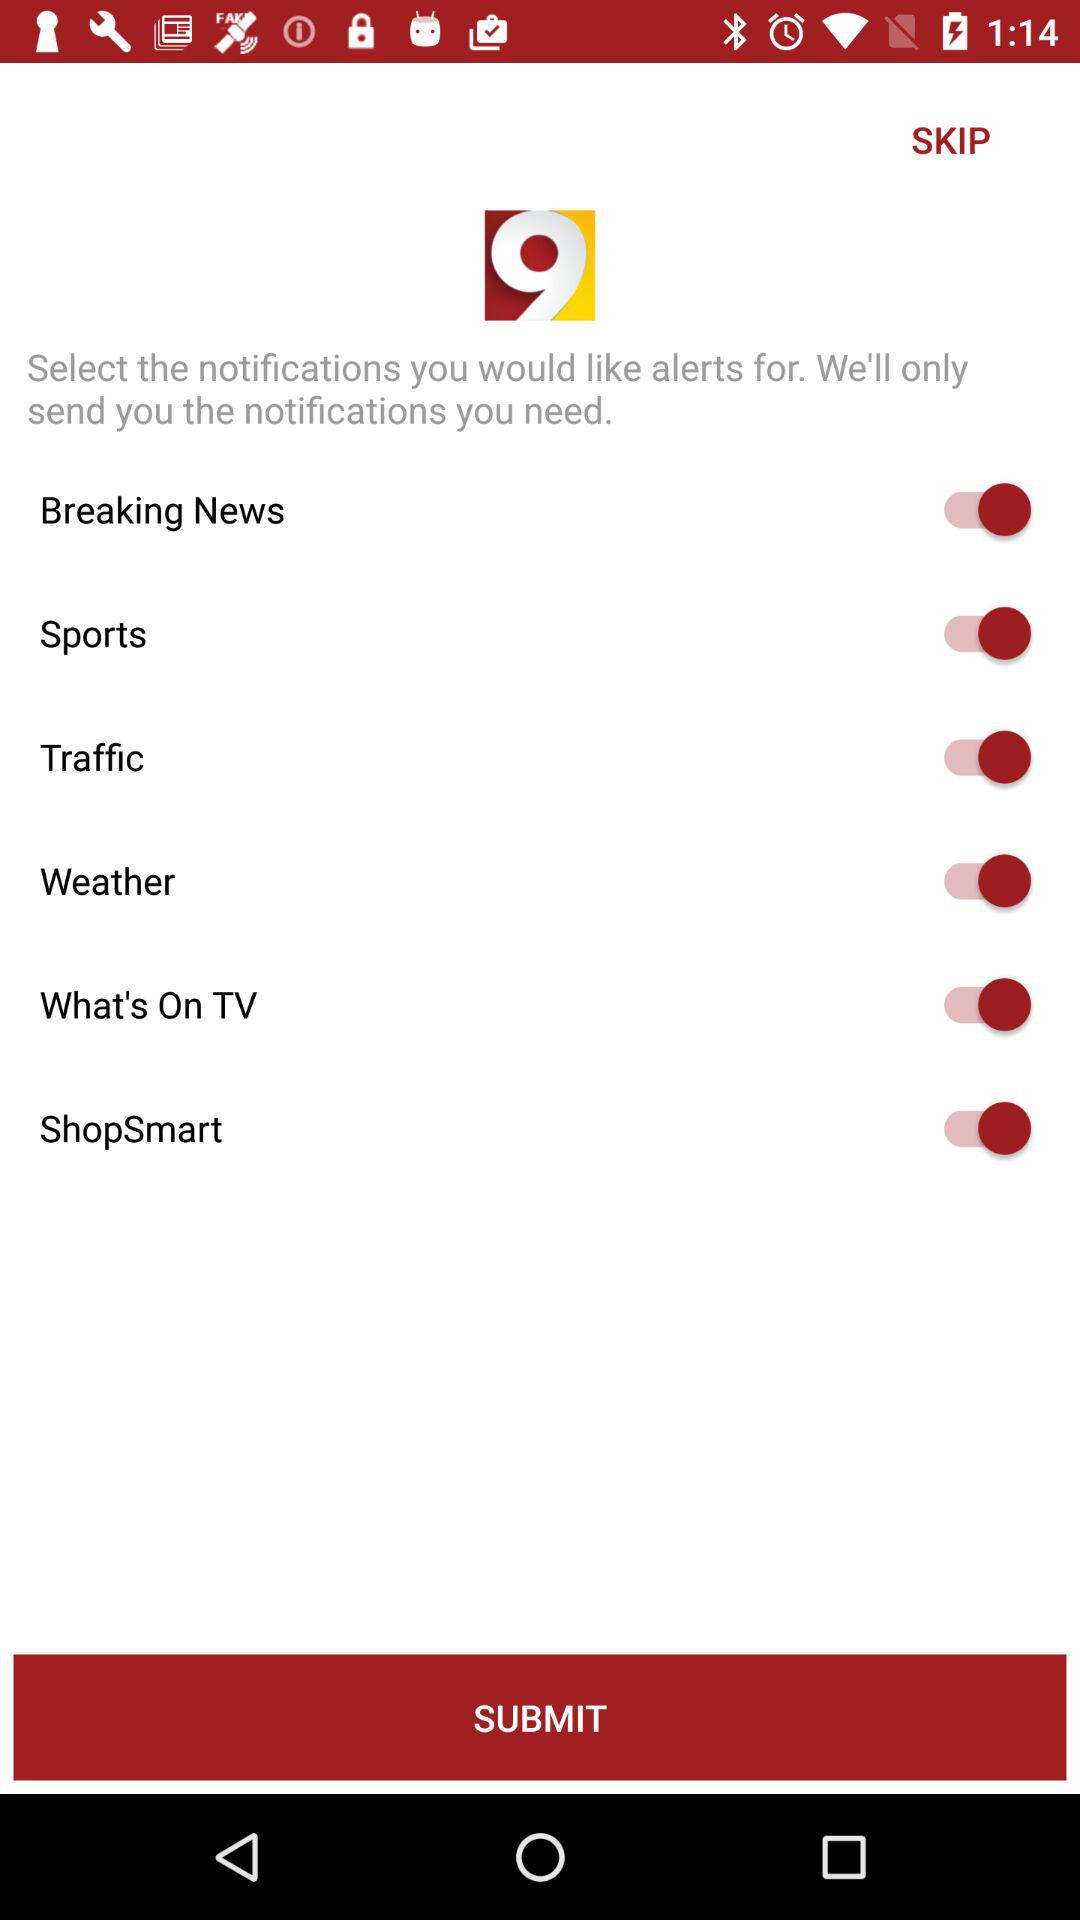What is the status of "Breaking News"? The status is "on". 